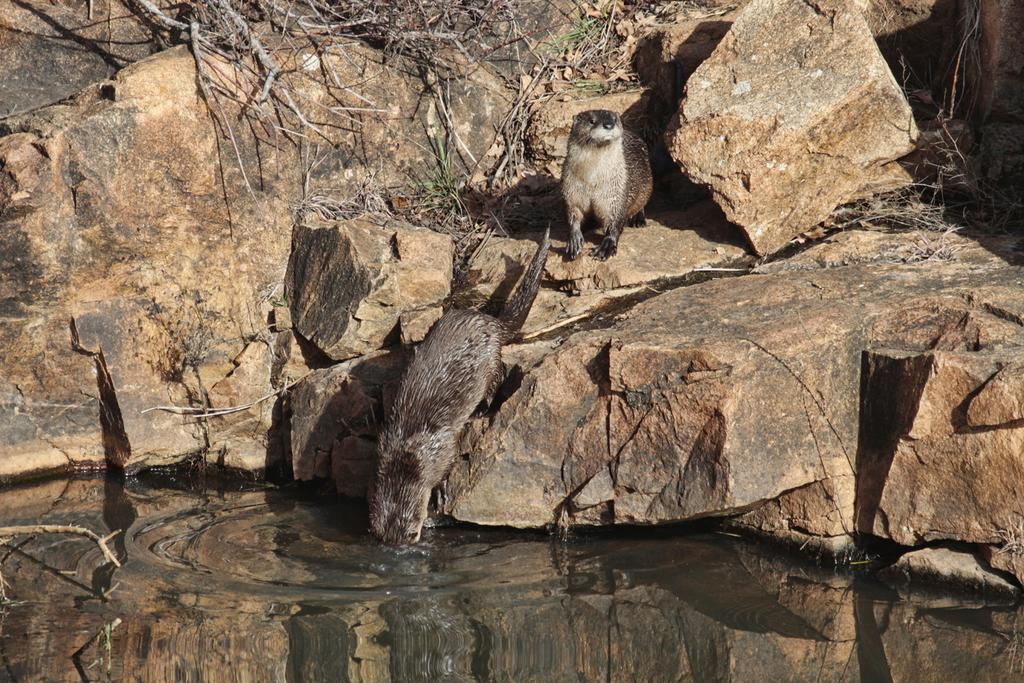What type of animals are in the image? There are animals in the image, but their specific type is not mentioned in the facts. Where are the animals located in the image? The animals are on a hill in the image. What can be seen at the bottom of the image? There is a lake at the bottom of the image. How many times do the animals kick a ball in the image? There is no ball present in the image, so the animals cannot kick a ball. Can you tell me how many nails the animals are holding in the image? There is no mention of nails or the animals holding anything in the image. 